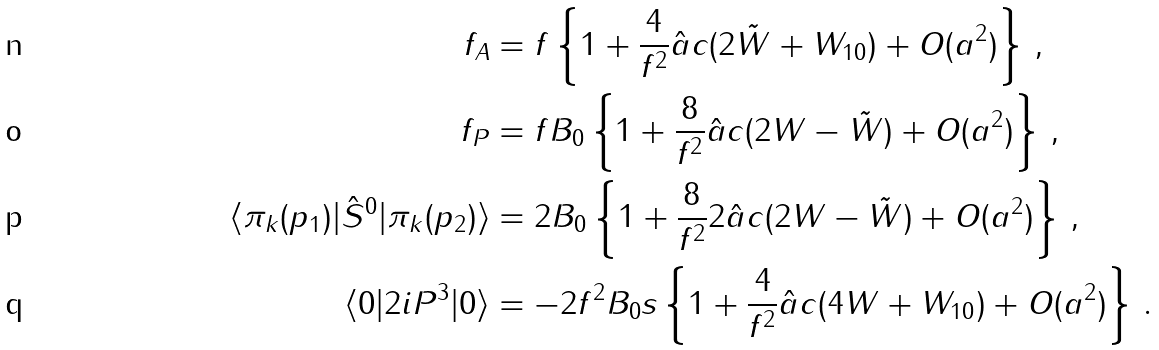<formula> <loc_0><loc_0><loc_500><loc_500>f _ { A } & = f \left \{ 1 + \frac { 4 } { f ^ { 2 } } \hat { a } c ( 2 \tilde { W } + W _ { 1 0 } ) + O ( a ^ { 2 } ) \right \} \, , \\ f _ { P } & = f B _ { 0 } \left \{ 1 + \frac { 8 } { f ^ { 2 } } \hat { a } c ( 2 W - \tilde { W } ) + O ( a ^ { 2 } ) \right \} \, , \\ \langle \pi _ { k } ( p _ { 1 } ) | \hat { S } ^ { 0 } | \pi _ { k } ( p _ { 2 } ) \rangle & = 2 B _ { 0 } \left \{ 1 + \frac { 8 } { f ^ { 2 } } 2 \hat { a } c ( 2 W - \tilde { W } ) + O ( a ^ { 2 } ) \right \} \, , \\ \langle 0 | 2 i P ^ { 3 } | 0 \rangle & = - 2 f ^ { 2 } B _ { 0 } s \left \{ 1 + \frac { 4 } { f ^ { 2 } } \hat { a } c ( 4 W + W _ { 1 0 } ) + O ( a ^ { 2 } ) \right \} \, .</formula> 